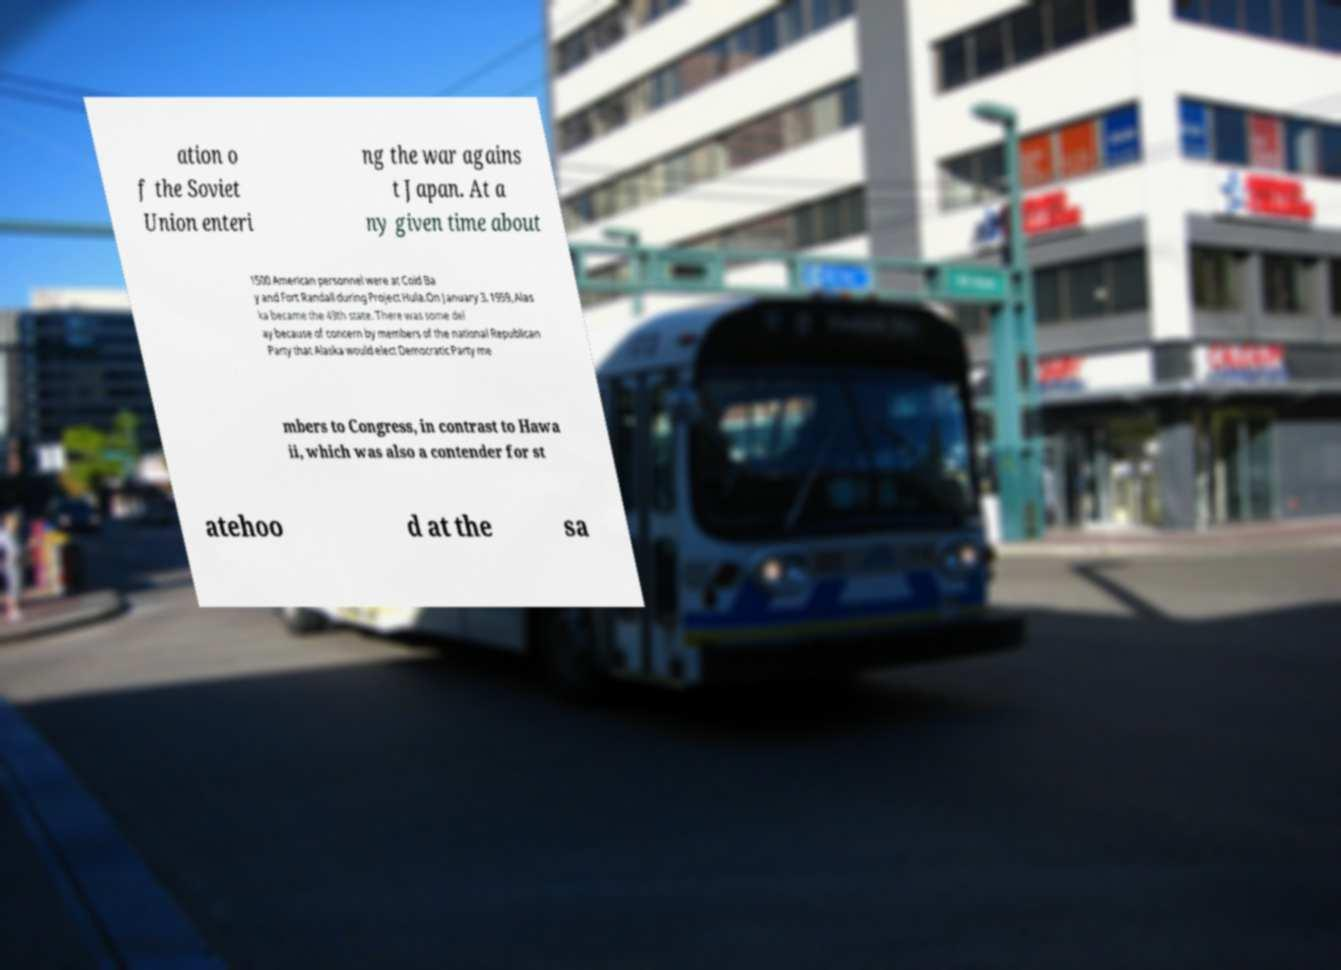For documentation purposes, I need the text within this image transcribed. Could you provide that? ation o f the Soviet Union enteri ng the war agains t Japan. At a ny given time about 1500 American personnel were at Cold Ba y and Fort Randall during Project Hula.On January 3, 1959, Alas ka became the 49th state. There was some del ay because of concern by members of the national Republican Party that Alaska would elect Democratic Party me mbers to Congress, in contrast to Hawa ii, which was also a contender for st atehoo d at the sa 